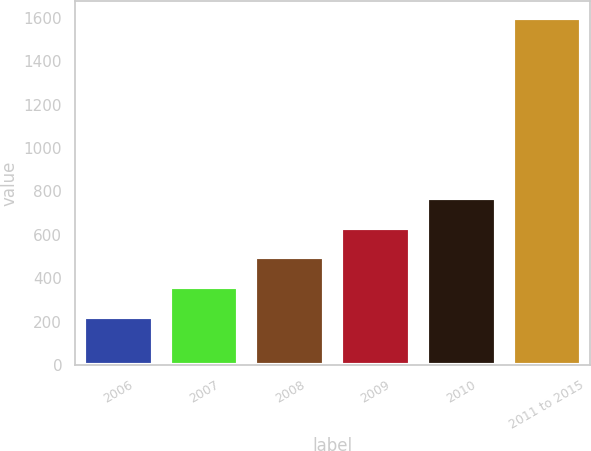Convert chart to OTSL. <chart><loc_0><loc_0><loc_500><loc_500><bar_chart><fcel>2006<fcel>2007<fcel>2008<fcel>2009<fcel>2010<fcel>2011 to 2015<nl><fcel>222<fcel>359.4<fcel>496.8<fcel>634.2<fcel>771.6<fcel>1596<nl></chart> 